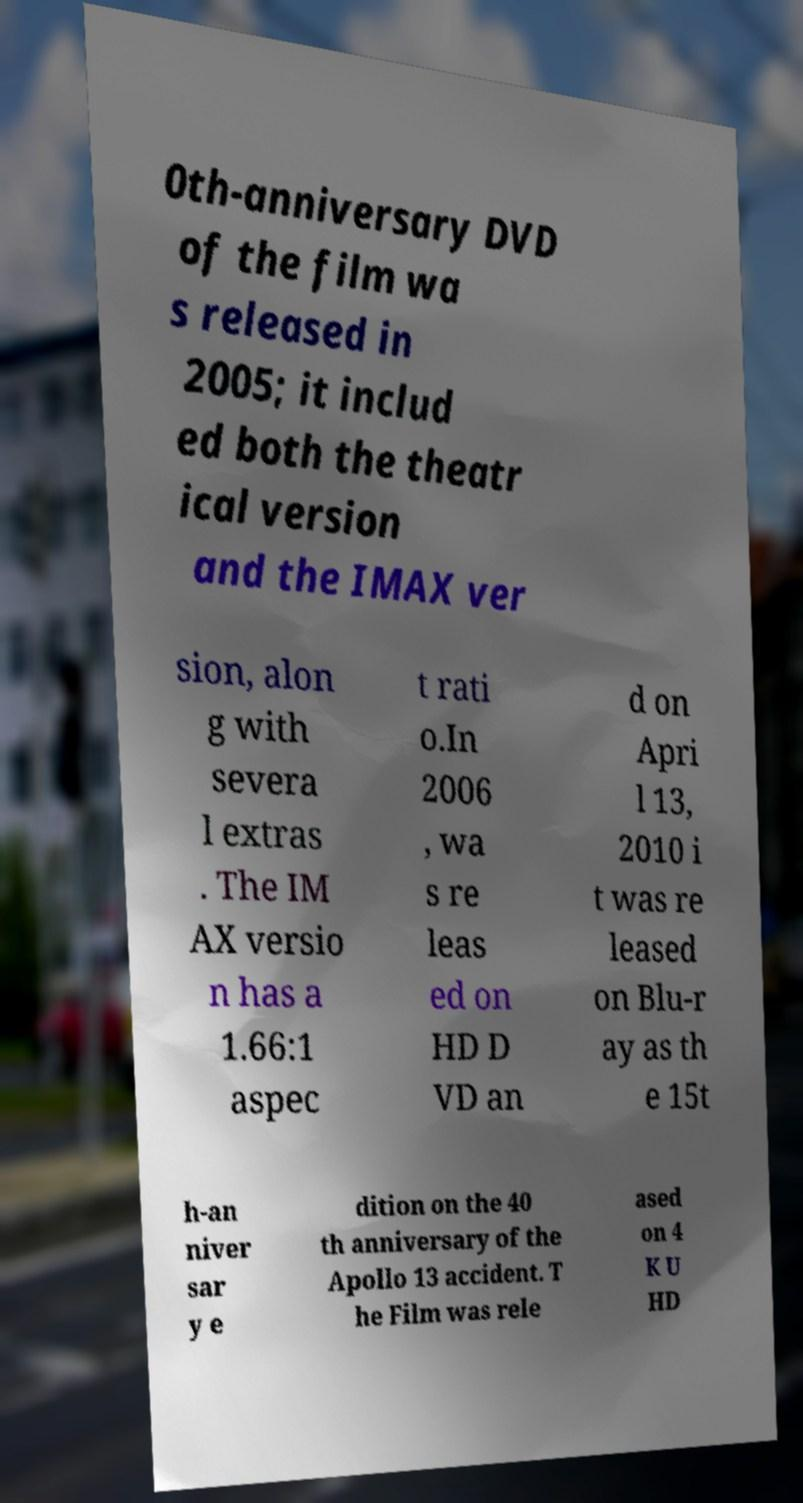Please read and relay the text visible in this image. What does it say? 0th-anniversary DVD of the film wa s released in 2005; it includ ed both the theatr ical version and the IMAX ver sion, alon g with severa l extras . The IM AX versio n has a 1.66:1 aspec t rati o.In 2006 , wa s re leas ed on HD D VD an d on Apri l 13, 2010 i t was re leased on Blu-r ay as th e 15t h-an niver sar y e dition on the 40 th anniversary of the Apollo 13 accident. T he Film was rele ased on 4 K U HD 